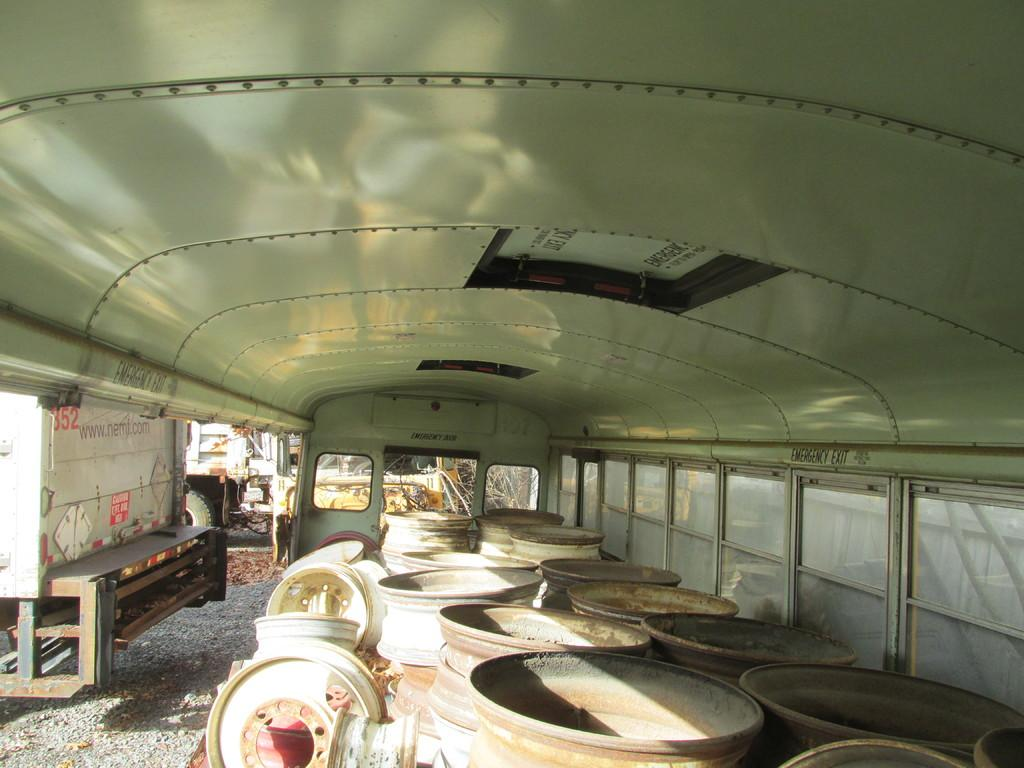What objects are in the foreground of the image? There are utensil pots and other items in the foreground of the image. Can you describe the objects in the background of the image? There is an electric box and a vehicle in the background of the image. What type of square furniture can be seen in the image? There is no square furniture present in the image. Whose teeth can be seen in the image? There are no teeth visible in the image. 